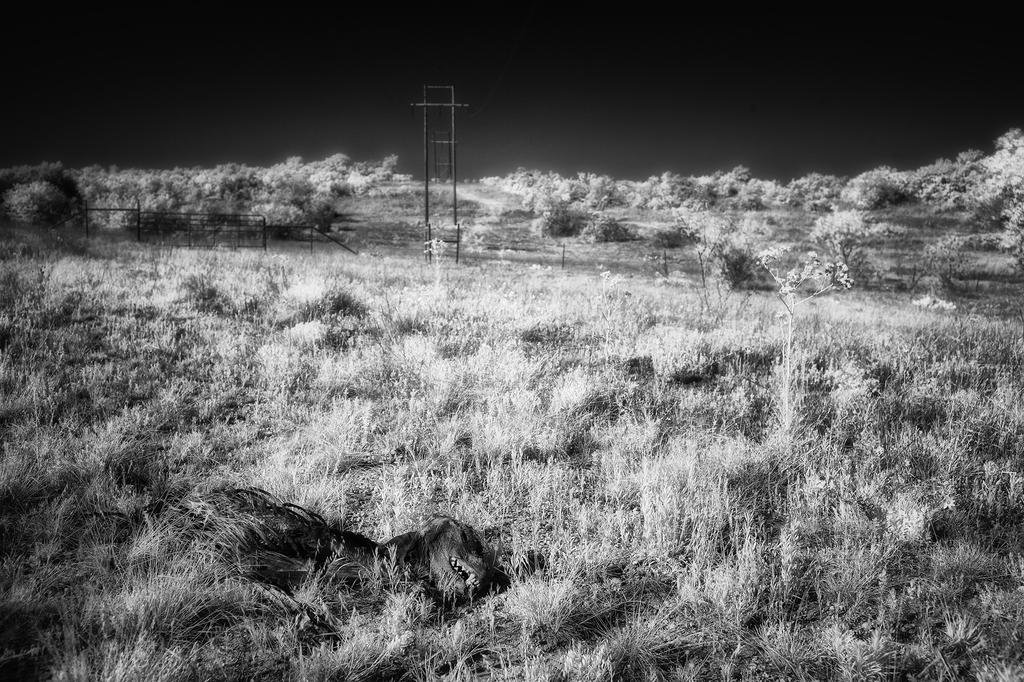What type of environment is shown in the image? The image depicts a forest. Can you describe the animal in the foreground? There is an animal on the grass in the foreground. What structures can be seen in the background? There is a railing and a pole in the background. What else is visible in the background? There are trees in the background. What is visible at the top of the image? The sky is visible at the top of the image. How many bananas are hanging from the trees in the image? There are no bananas visible in the image; it depicts a forest with trees. What day of the week is it in the image? The image does not provide information about the day of the week; it only shows a forest with an animal, railing, pole, trees, and the sky. 